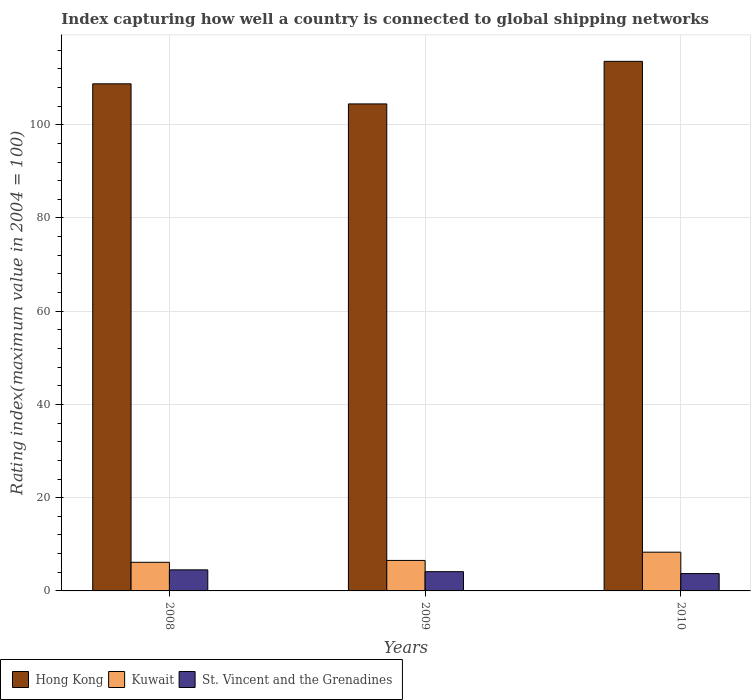How many groups of bars are there?
Give a very brief answer. 3. Are the number of bars per tick equal to the number of legend labels?
Keep it short and to the point. Yes. Are the number of bars on each tick of the X-axis equal?
Make the answer very short. Yes. How many bars are there on the 3rd tick from the left?
Your answer should be compact. 3. What is the rating index in Hong Kong in 2008?
Provide a short and direct response. 108.78. Across all years, what is the maximum rating index in St. Vincent and the Grenadines?
Keep it short and to the point. 4.52. Across all years, what is the minimum rating index in St. Vincent and the Grenadines?
Give a very brief answer. 3.72. In which year was the rating index in Kuwait minimum?
Make the answer very short. 2008. What is the total rating index in Hong Kong in the graph?
Your response must be concise. 326.85. What is the difference between the rating index in Kuwait in 2008 and that in 2010?
Provide a short and direct response. -2.17. What is the difference between the rating index in Kuwait in 2008 and the rating index in Hong Kong in 2009?
Your answer should be very brief. -98.33. What is the average rating index in Kuwait per year?
Make the answer very short. 7. In the year 2009, what is the difference between the rating index in St. Vincent and the Grenadines and rating index in Hong Kong?
Give a very brief answer. -100.34. In how many years, is the rating index in Kuwait greater than 72?
Make the answer very short. 0. What is the ratio of the rating index in Kuwait in 2008 to that in 2010?
Provide a succinct answer. 0.74. Is the difference between the rating index in St. Vincent and the Grenadines in 2009 and 2010 greater than the difference between the rating index in Hong Kong in 2009 and 2010?
Keep it short and to the point. Yes. What is the difference between the highest and the second highest rating index in Kuwait?
Give a very brief answer. 1.77. What is the difference between the highest and the lowest rating index in Kuwait?
Ensure brevity in your answer.  2.17. In how many years, is the rating index in Kuwait greater than the average rating index in Kuwait taken over all years?
Provide a short and direct response. 1. What does the 2nd bar from the left in 2009 represents?
Give a very brief answer. Kuwait. What does the 3rd bar from the right in 2010 represents?
Your answer should be very brief. Hong Kong. How many bars are there?
Your answer should be compact. 9. Are all the bars in the graph horizontal?
Your answer should be compact. No. What is the difference between two consecutive major ticks on the Y-axis?
Make the answer very short. 20. Are the values on the major ticks of Y-axis written in scientific E-notation?
Your answer should be compact. No. Does the graph contain grids?
Make the answer very short. Yes. Where does the legend appear in the graph?
Your answer should be compact. Bottom left. How many legend labels are there?
Keep it short and to the point. 3. What is the title of the graph?
Your answer should be very brief. Index capturing how well a country is connected to global shipping networks. What is the label or title of the Y-axis?
Ensure brevity in your answer.  Rating index(maximum value in 2004 = 100). What is the Rating index(maximum value in 2004 = 100) of Hong Kong in 2008?
Your answer should be very brief. 108.78. What is the Rating index(maximum value in 2004 = 100) of Kuwait in 2008?
Offer a terse response. 6.14. What is the Rating index(maximum value in 2004 = 100) in St. Vincent and the Grenadines in 2008?
Your answer should be very brief. 4.52. What is the Rating index(maximum value in 2004 = 100) of Hong Kong in 2009?
Give a very brief answer. 104.47. What is the Rating index(maximum value in 2004 = 100) in Kuwait in 2009?
Ensure brevity in your answer.  6.54. What is the Rating index(maximum value in 2004 = 100) of St. Vincent and the Grenadines in 2009?
Offer a terse response. 4.13. What is the Rating index(maximum value in 2004 = 100) in Hong Kong in 2010?
Provide a short and direct response. 113.6. What is the Rating index(maximum value in 2004 = 100) of Kuwait in 2010?
Provide a short and direct response. 8.31. What is the Rating index(maximum value in 2004 = 100) of St. Vincent and the Grenadines in 2010?
Offer a very short reply. 3.72. Across all years, what is the maximum Rating index(maximum value in 2004 = 100) in Hong Kong?
Give a very brief answer. 113.6. Across all years, what is the maximum Rating index(maximum value in 2004 = 100) of Kuwait?
Give a very brief answer. 8.31. Across all years, what is the maximum Rating index(maximum value in 2004 = 100) in St. Vincent and the Grenadines?
Provide a succinct answer. 4.52. Across all years, what is the minimum Rating index(maximum value in 2004 = 100) of Hong Kong?
Give a very brief answer. 104.47. Across all years, what is the minimum Rating index(maximum value in 2004 = 100) in Kuwait?
Your answer should be compact. 6.14. Across all years, what is the minimum Rating index(maximum value in 2004 = 100) of St. Vincent and the Grenadines?
Provide a short and direct response. 3.72. What is the total Rating index(maximum value in 2004 = 100) of Hong Kong in the graph?
Offer a terse response. 326.85. What is the total Rating index(maximum value in 2004 = 100) in Kuwait in the graph?
Keep it short and to the point. 20.99. What is the total Rating index(maximum value in 2004 = 100) in St. Vincent and the Grenadines in the graph?
Your answer should be compact. 12.37. What is the difference between the Rating index(maximum value in 2004 = 100) in Hong Kong in 2008 and that in 2009?
Ensure brevity in your answer.  4.31. What is the difference between the Rating index(maximum value in 2004 = 100) in Kuwait in 2008 and that in 2009?
Offer a terse response. -0.4. What is the difference between the Rating index(maximum value in 2004 = 100) of St. Vincent and the Grenadines in 2008 and that in 2009?
Provide a succinct answer. 0.39. What is the difference between the Rating index(maximum value in 2004 = 100) in Hong Kong in 2008 and that in 2010?
Your answer should be compact. -4.82. What is the difference between the Rating index(maximum value in 2004 = 100) in Kuwait in 2008 and that in 2010?
Keep it short and to the point. -2.17. What is the difference between the Rating index(maximum value in 2004 = 100) of Hong Kong in 2009 and that in 2010?
Provide a short and direct response. -9.13. What is the difference between the Rating index(maximum value in 2004 = 100) of Kuwait in 2009 and that in 2010?
Make the answer very short. -1.77. What is the difference between the Rating index(maximum value in 2004 = 100) of St. Vincent and the Grenadines in 2009 and that in 2010?
Offer a terse response. 0.41. What is the difference between the Rating index(maximum value in 2004 = 100) of Hong Kong in 2008 and the Rating index(maximum value in 2004 = 100) of Kuwait in 2009?
Offer a terse response. 102.24. What is the difference between the Rating index(maximum value in 2004 = 100) of Hong Kong in 2008 and the Rating index(maximum value in 2004 = 100) of St. Vincent and the Grenadines in 2009?
Provide a short and direct response. 104.65. What is the difference between the Rating index(maximum value in 2004 = 100) in Kuwait in 2008 and the Rating index(maximum value in 2004 = 100) in St. Vincent and the Grenadines in 2009?
Make the answer very short. 2.01. What is the difference between the Rating index(maximum value in 2004 = 100) of Hong Kong in 2008 and the Rating index(maximum value in 2004 = 100) of Kuwait in 2010?
Ensure brevity in your answer.  100.47. What is the difference between the Rating index(maximum value in 2004 = 100) of Hong Kong in 2008 and the Rating index(maximum value in 2004 = 100) of St. Vincent and the Grenadines in 2010?
Provide a succinct answer. 105.06. What is the difference between the Rating index(maximum value in 2004 = 100) of Kuwait in 2008 and the Rating index(maximum value in 2004 = 100) of St. Vincent and the Grenadines in 2010?
Provide a succinct answer. 2.42. What is the difference between the Rating index(maximum value in 2004 = 100) of Hong Kong in 2009 and the Rating index(maximum value in 2004 = 100) of Kuwait in 2010?
Give a very brief answer. 96.16. What is the difference between the Rating index(maximum value in 2004 = 100) in Hong Kong in 2009 and the Rating index(maximum value in 2004 = 100) in St. Vincent and the Grenadines in 2010?
Your answer should be very brief. 100.75. What is the difference between the Rating index(maximum value in 2004 = 100) of Kuwait in 2009 and the Rating index(maximum value in 2004 = 100) of St. Vincent and the Grenadines in 2010?
Your answer should be compact. 2.82. What is the average Rating index(maximum value in 2004 = 100) in Hong Kong per year?
Your answer should be very brief. 108.95. What is the average Rating index(maximum value in 2004 = 100) of Kuwait per year?
Make the answer very short. 7. What is the average Rating index(maximum value in 2004 = 100) of St. Vincent and the Grenadines per year?
Keep it short and to the point. 4.12. In the year 2008, what is the difference between the Rating index(maximum value in 2004 = 100) in Hong Kong and Rating index(maximum value in 2004 = 100) in Kuwait?
Offer a terse response. 102.64. In the year 2008, what is the difference between the Rating index(maximum value in 2004 = 100) in Hong Kong and Rating index(maximum value in 2004 = 100) in St. Vincent and the Grenadines?
Your answer should be very brief. 104.26. In the year 2008, what is the difference between the Rating index(maximum value in 2004 = 100) in Kuwait and Rating index(maximum value in 2004 = 100) in St. Vincent and the Grenadines?
Your answer should be very brief. 1.62. In the year 2009, what is the difference between the Rating index(maximum value in 2004 = 100) of Hong Kong and Rating index(maximum value in 2004 = 100) of Kuwait?
Offer a very short reply. 97.93. In the year 2009, what is the difference between the Rating index(maximum value in 2004 = 100) in Hong Kong and Rating index(maximum value in 2004 = 100) in St. Vincent and the Grenadines?
Make the answer very short. 100.34. In the year 2009, what is the difference between the Rating index(maximum value in 2004 = 100) in Kuwait and Rating index(maximum value in 2004 = 100) in St. Vincent and the Grenadines?
Your response must be concise. 2.41. In the year 2010, what is the difference between the Rating index(maximum value in 2004 = 100) in Hong Kong and Rating index(maximum value in 2004 = 100) in Kuwait?
Offer a very short reply. 105.29. In the year 2010, what is the difference between the Rating index(maximum value in 2004 = 100) in Hong Kong and Rating index(maximum value in 2004 = 100) in St. Vincent and the Grenadines?
Your answer should be very brief. 109.88. In the year 2010, what is the difference between the Rating index(maximum value in 2004 = 100) of Kuwait and Rating index(maximum value in 2004 = 100) of St. Vincent and the Grenadines?
Ensure brevity in your answer.  4.59. What is the ratio of the Rating index(maximum value in 2004 = 100) of Hong Kong in 2008 to that in 2009?
Provide a succinct answer. 1.04. What is the ratio of the Rating index(maximum value in 2004 = 100) in Kuwait in 2008 to that in 2009?
Provide a succinct answer. 0.94. What is the ratio of the Rating index(maximum value in 2004 = 100) of St. Vincent and the Grenadines in 2008 to that in 2009?
Keep it short and to the point. 1.09. What is the ratio of the Rating index(maximum value in 2004 = 100) in Hong Kong in 2008 to that in 2010?
Offer a very short reply. 0.96. What is the ratio of the Rating index(maximum value in 2004 = 100) of Kuwait in 2008 to that in 2010?
Offer a very short reply. 0.74. What is the ratio of the Rating index(maximum value in 2004 = 100) in St. Vincent and the Grenadines in 2008 to that in 2010?
Provide a short and direct response. 1.22. What is the ratio of the Rating index(maximum value in 2004 = 100) of Hong Kong in 2009 to that in 2010?
Your answer should be very brief. 0.92. What is the ratio of the Rating index(maximum value in 2004 = 100) of Kuwait in 2009 to that in 2010?
Provide a short and direct response. 0.79. What is the ratio of the Rating index(maximum value in 2004 = 100) of St. Vincent and the Grenadines in 2009 to that in 2010?
Provide a succinct answer. 1.11. What is the difference between the highest and the second highest Rating index(maximum value in 2004 = 100) in Hong Kong?
Your answer should be very brief. 4.82. What is the difference between the highest and the second highest Rating index(maximum value in 2004 = 100) in Kuwait?
Ensure brevity in your answer.  1.77. What is the difference between the highest and the second highest Rating index(maximum value in 2004 = 100) in St. Vincent and the Grenadines?
Make the answer very short. 0.39. What is the difference between the highest and the lowest Rating index(maximum value in 2004 = 100) in Hong Kong?
Give a very brief answer. 9.13. What is the difference between the highest and the lowest Rating index(maximum value in 2004 = 100) in Kuwait?
Keep it short and to the point. 2.17. What is the difference between the highest and the lowest Rating index(maximum value in 2004 = 100) of St. Vincent and the Grenadines?
Give a very brief answer. 0.8. 